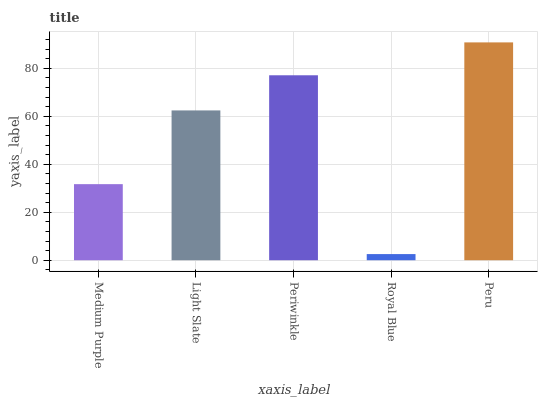Is Royal Blue the minimum?
Answer yes or no. Yes. Is Peru the maximum?
Answer yes or no. Yes. Is Light Slate the minimum?
Answer yes or no. No. Is Light Slate the maximum?
Answer yes or no. No. Is Light Slate greater than Medium Purple?
Answer yes or no. Yes. Is Medium Purple less than Light Slate?
Answer yes or no. Yes. Is Medium Purple greater than Light Slate?
Answer yes or no. No. Is Light Slate less than Medium Purple?
Answer yes or no. No. Is Light Slate the high median?
Answer yes or no. Yes. Is Light Slate the low median?
Answer yes or no. Yes. Is Medium Purple the high median?
Answer yes or no. No. Is Royal Blue the low median?
Answer yes or no. No. 